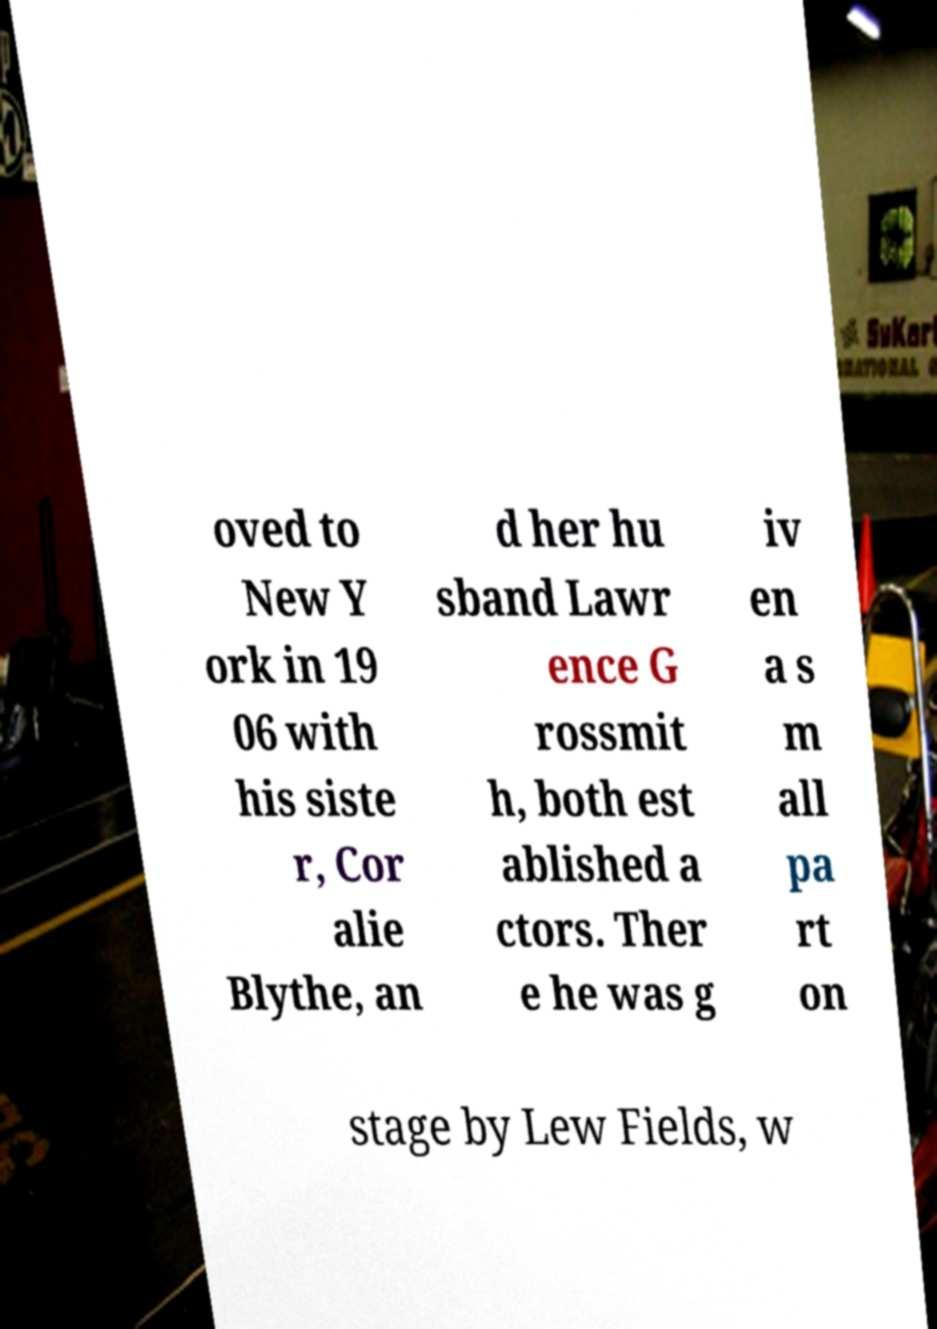I need the written content from this picture converted into text. Can you do that? oved to New Y ork in 19 06 with his siste r, Cor alie Blythe, an d her hu sband Lawr ence G rossmit h, both est ablished a ctors. Ther e he was g iv en a s m all pa rt on stage by Lew Fields, w 